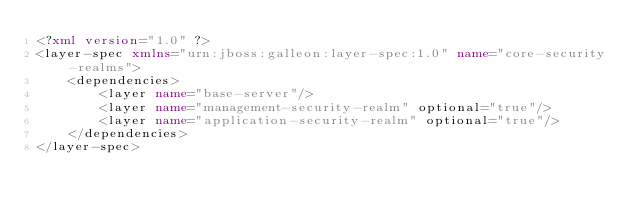<code> <loc_0><loc_0><loc_500><loc_500><_XML_><?xml version="1.0" ?>
<layer-spec xmlns="urn:jboss:galleon:layer-spec:1.0" name="core-security-realms">
    <dependencies>
        <layer name="base-server"/>
        <layer name="management-security-realm" optional="true"/>
        <layer name="application-security-realm" optional="true"/>
    </dependencies>
</layer-spec>
</code> 